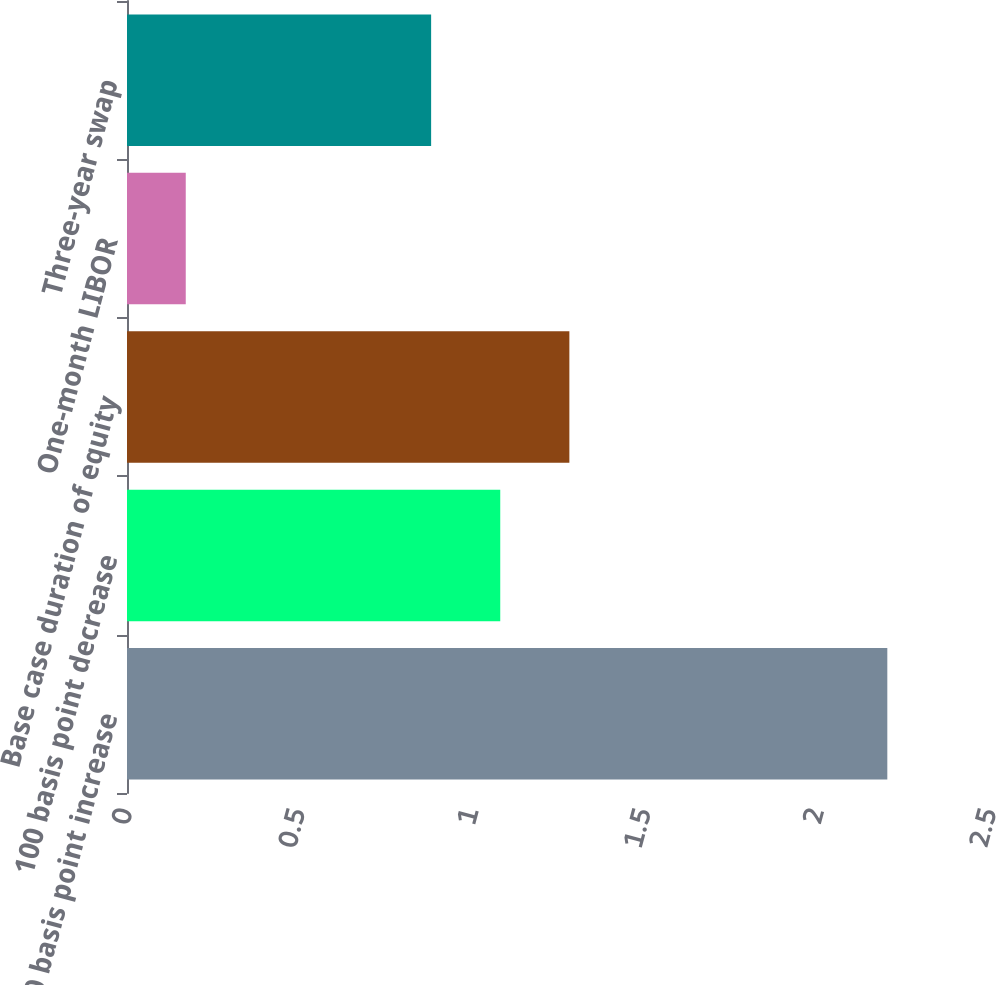Convert chart to OTSL. <chart><loc_0><loc_0><loc_500><loc_500><bar_chart><fcel>100 basis point increase<fcel>100 basis point decrease<fcel>Base case duration of equity<fcel>One-month LIBOR<fcel>Three-year swap<nl><fcel>2.2<fcel>1.08<fcel>1.28<fcel>0.17<fcel>0.88<nl></chart> 